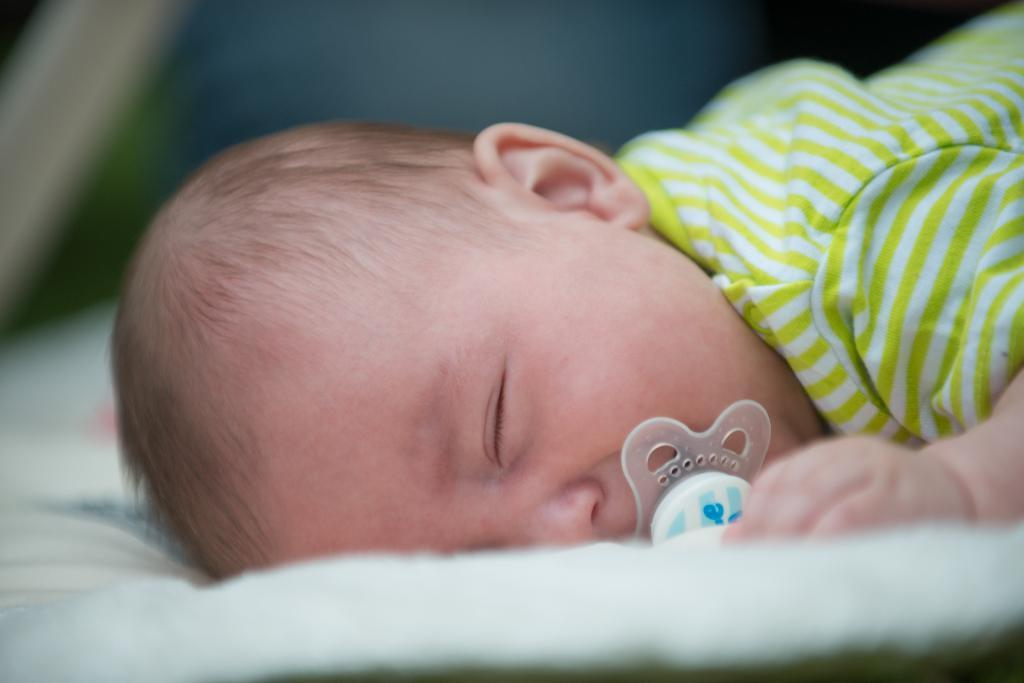What is the main subject of the image? There is a baby in the image. What is the baby doing in the image? The baby is sleeping. Is there anything unusual about the baby's appearance in the image? Yes, there is a zipper in the baby's mouth. What can be seen at the bottom of the image? There is a cloth at the bottom of the image. What type of store can be seen in the image? There is no store present in the image. 